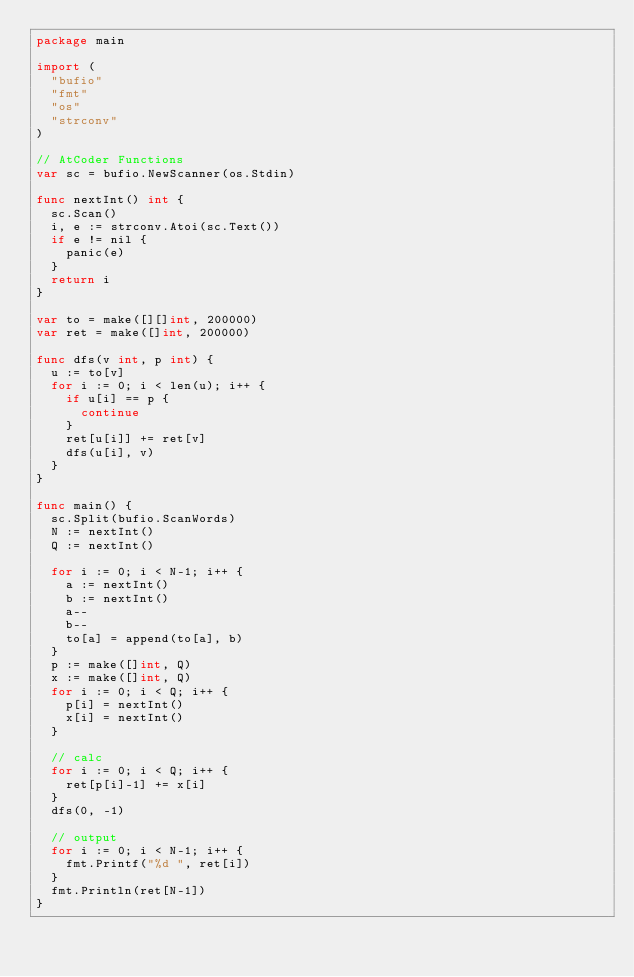<code> <loc_0><loc_0><loc_500><loc_500><_Go_>package main

import (
	"bufio"
	"fmt"
	"os"
	"strconv"
)

// AtCoder Functions
var sc = bufio.NewScanner(os.Stdin)

func nextInt() int {
	sc.Scan()
	i, e := strconv.Atoi(sc.Text())
	if e != nil {
		panic(e)
	}
	return i
}

var to = make([][]int, 200000)
var ret = make([]int, 200000)

func dfs(v int, p int) {
	u := to[v]
	for i := 0; i < len(u); i++ {
		if u[i] == p {
			continue
		}
		ret[u[i]] += ret[v]
		dfs(u[i], v)
	}
}

func main() {
	sc.Split(bufio.ScanWords)
	N := nextInt()
	Q := nextInt()

	for i := 0; i < N-1; i++ {
		a := nextInt()
		b := nextInt()
		a--
		b--
		to[a] = append(to[a], b)
	}
	p := make([]int, Q)
	x := make([]int, Q)
	for i := 0; i < Q; i++ {
		p[i] = nextInt()
		x[i] = nextInt()
	}

	// calc
	for i := 0; i < Q; i++ {
		ret[p[i]-1] += x[i]
	}
	dfs(0, -1)

	// output
	for i := 0; i < N-1; i++ {
		fmt.Printf("%d ", ret[i])
	}
	fmt.Println(ret[N-1])
}
</code> 